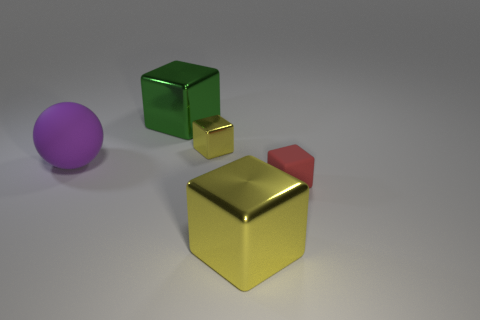Add 3 large cylinders. How many objects exist? 8 Subtract all blocks. How many objects are left? 1 Subtract all tiny cyan blocks. Subtract all cubes. How many objects are left? 1 Add 3 tiny yellow metal cubes. How many tiny yellow metal cubes are left? 4 Add 2 green metal blocks. How many green metal blocks exist? 3 Subtract 0 yellow balls. How many objects are left? 5 